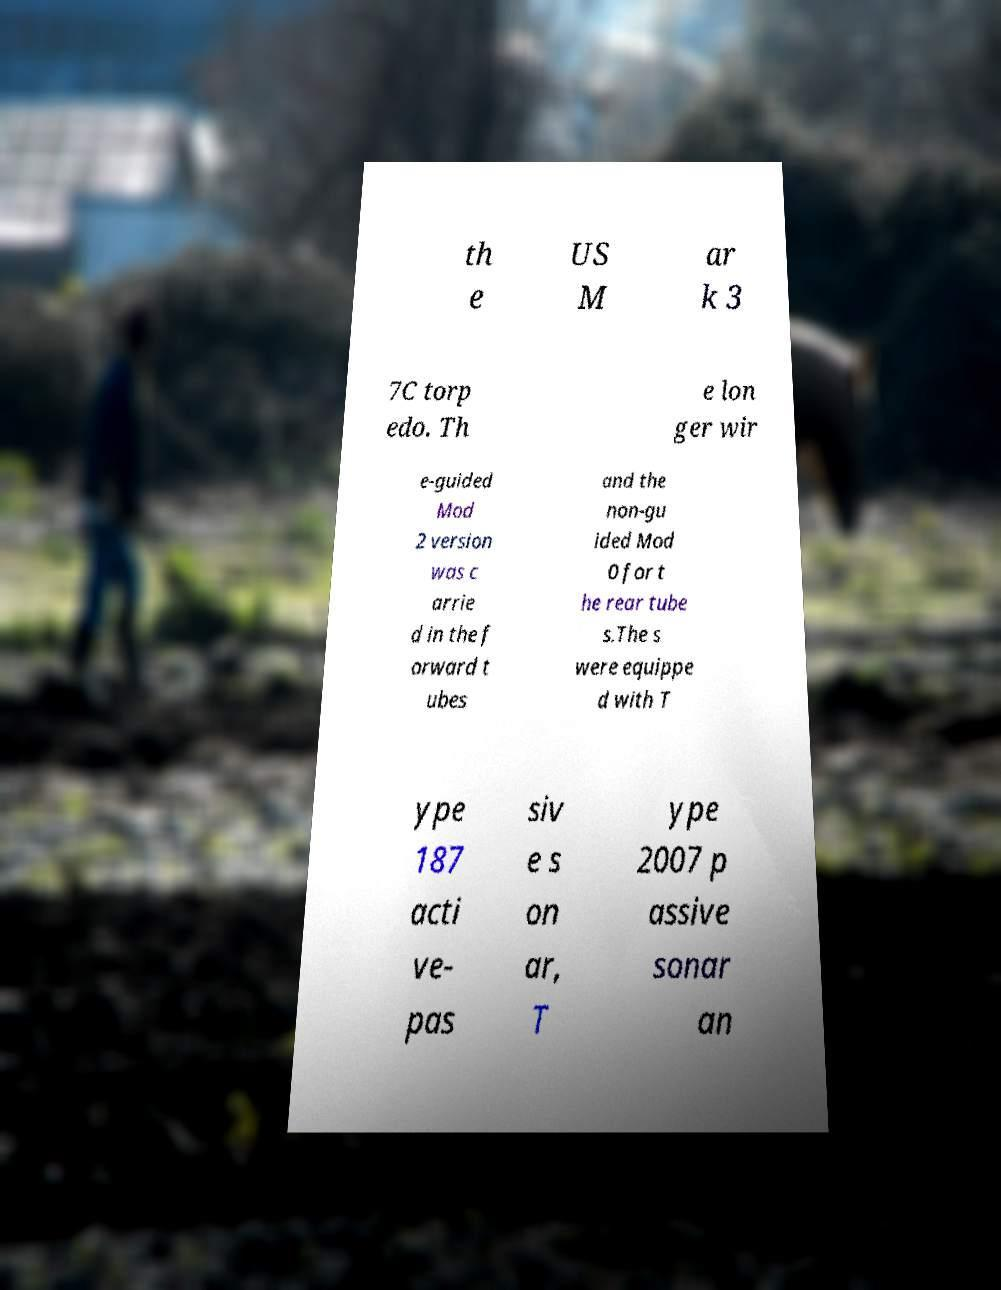Could you extract and type out the text from this image? th e US M ar k 3 7C torp edo. Th e lon ger wir e-guided Mod 2 version was c arrie d in the f orward t ubes and the non-gu ided Mod 0 for t he rear tube s.The s were equippe d with T ype 187 acti ve- pas siv e s on ar, T ype 2007 p assive sonar an 